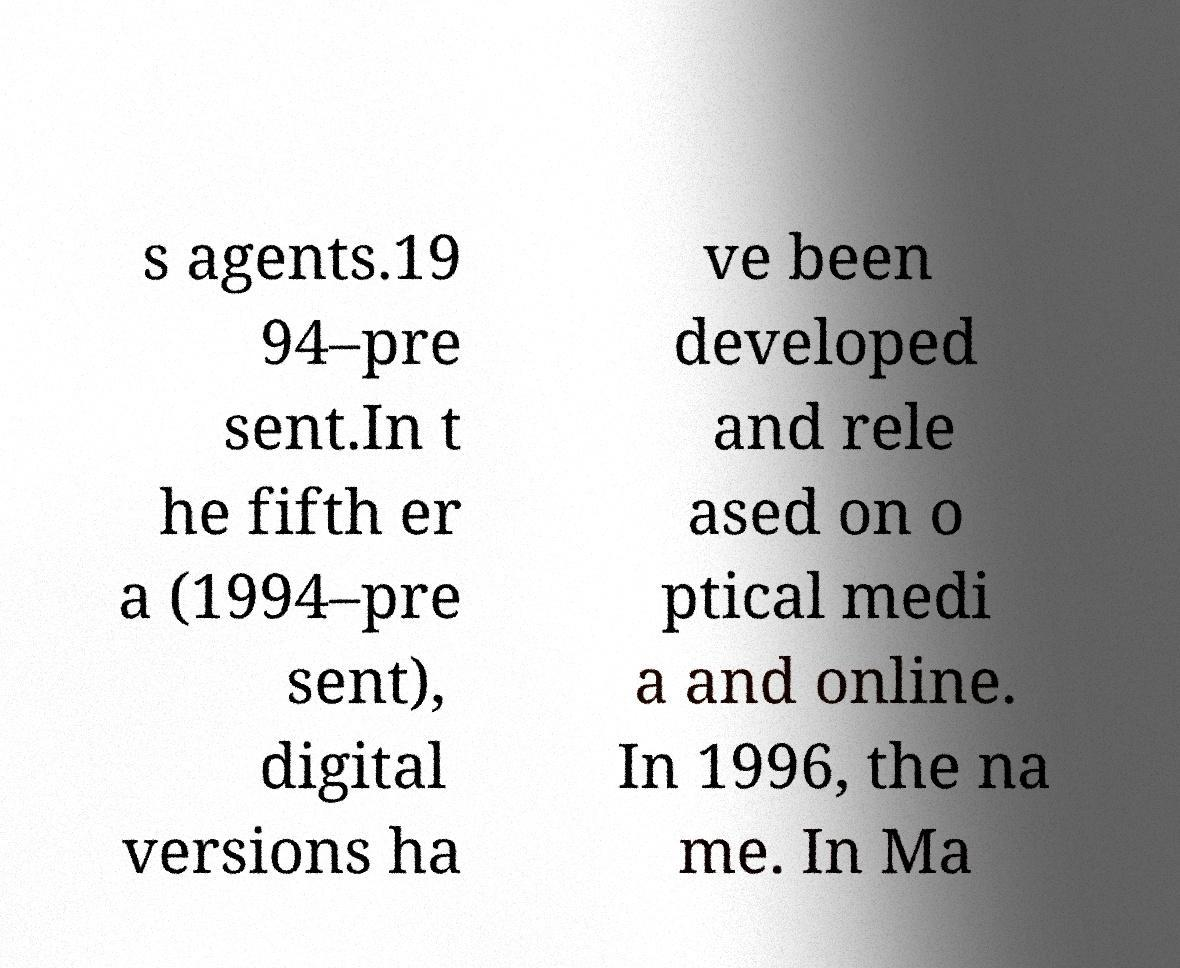There's text embedded in this image that I need extracted. Can you transcribe it verbatim? s agents.19 94–pre sent.In t he fifth er a (1994–pre sent), digital versions ha ve been developed and rele ased on o ptical medi a and online. In 1996, the na me. In Ma 